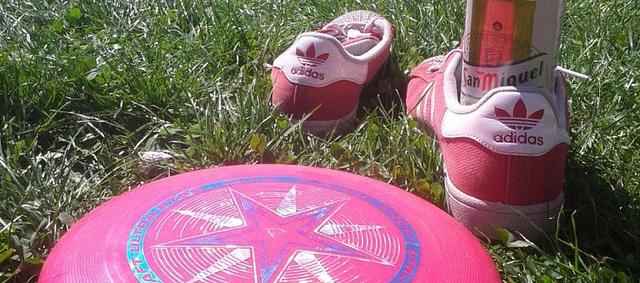What brand is the shoes?
Write a very short answer. Adidas. What is in the shoe?
Short answer required. Beer. What size shoe are they?
Short answer required. 9. 